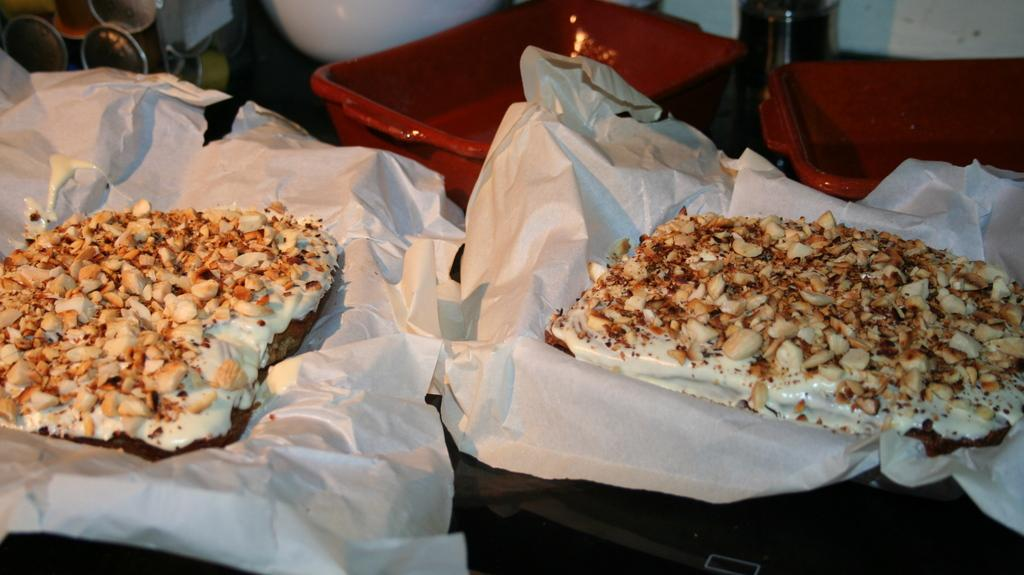Where was the image taken? The image was taken indoors. What can be seen in the middle of the image? There are two trays with butter paper and food items in the middle of the image. How many empty trays are visible in the image? There are two empty trays in the image. What else can be observed on the table in the image? There are a few objects on the table. What type of tooth is visible on the table in the image? There is no tooth present on the table in the image. Is there a stove visible in the image? No, there is no stove visible in the image. 